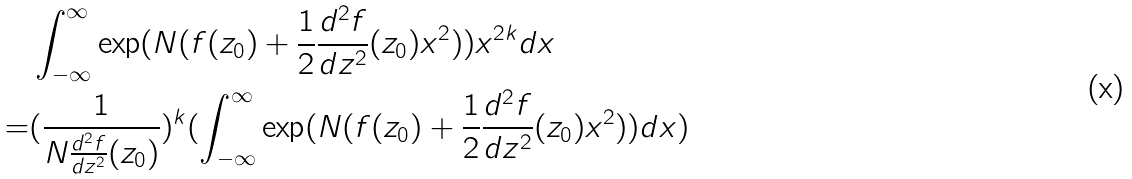<formula> <loc_0><loc_0><loc_500><loc_500>& \int _ { - \infty } ^ { \infty } \exp ( N ( f ( z _ { 0 } ) + \frac { 1 } { 2 } \frac { d ^ { 2 } f } { d z ^ { 2 } } ( z _ { 0 } ) x ^ { 2 } ) ) x ^ { 2 k } d x \\ = & ( \frac { 1 } { N \frac { d ^ { 2 } f } { d z ^ { 2 } } ( z _ { 0 } ) } ) ^ { k } ( \int _ { - \infty } ^ { \infty } \exp ( N ( f ( z _ { 0 } ) + \frac { 1 } { 2 } \frac { d ^ { 2 } f } { d z ^ { 2 } } ( z _ { 0 } ) x ^ { 2 } ) ) d x )</formula> 